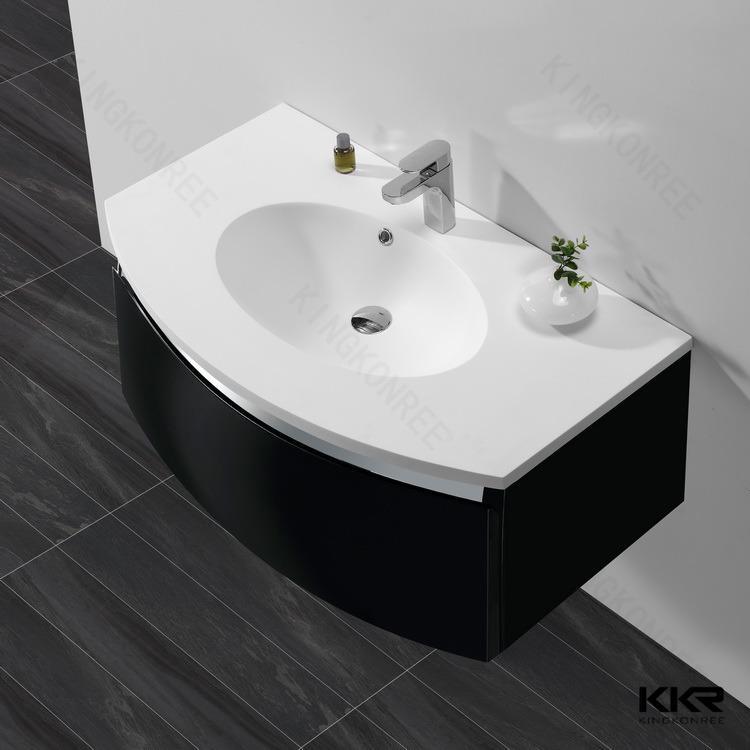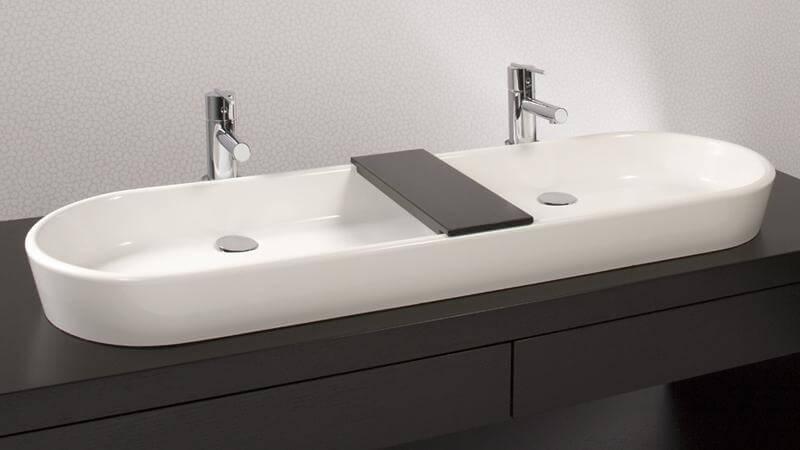The first image is the image on the left, the second image is the image on the right. Examine the images to the left and right. Is the description "A bathroom double sink installation has one upright chrome faucet fixture situated behind the bowl of each sink" accurate? Answer yes or no. Yes. The first image is the image on the left, the second image is the image on the right. For the images shown, is this caption "There are two basins on the counter in the image on the right." true? Answer yes or no. Yes. 